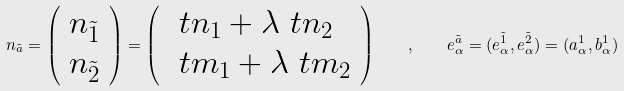<formula> <loc_0><loc_0><loc_500><loc_500>n _ { \tilde { a } } = \left ( \begin{array} { l } n _ { \tilde { 1 } } \\ n _ { \tilde { 2 } } \end{array} \right ) = \left ( \begin{array} { l } \ t n _ { 1 } + \lambda \ t n _ { 2 } \\ \ t m _ { 1 } + \lambda \ t m _ { 2 } \\ \end{array} \right ) \quad , \quad e _ { \alpha } ^ { \tilde { a } } = ( e _ { \alpha } ^ { \tilde { 1 } } , e _ { \alpha } ^ { \tilde { 2 } } ) = ( a _ { \alpha } ^ { 1 } , b _ { \alpha } ^ { 1 } )</formula> 